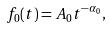Convert formula to latex. <formula><loc_0><loc_0><loc_500><loc_500>f _ { 0 } ( t ) = A _ { 0 } t ^ { - \alpha _ { 0 } } ,</formula> 